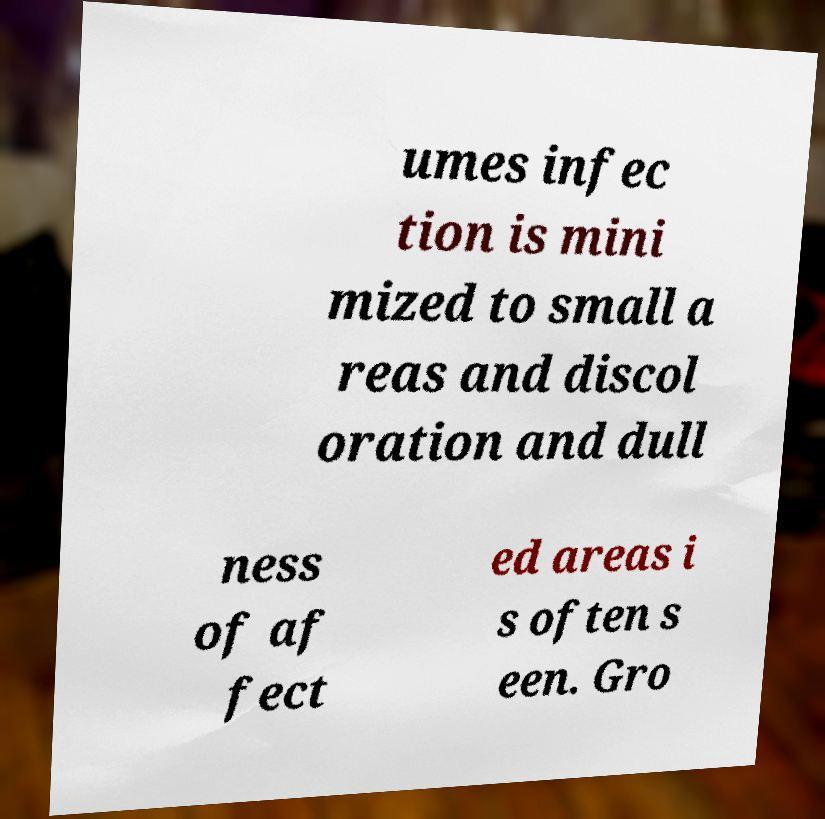Can you read and provide the text displayed in the image?This photo seems to have some interesting text. Can you extract and type it out for me? umes infec tion is mini mized to small a reas and discol oration and dull ness of af fect ed areas i s often s een. Gro 